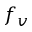Convert formula to latex. <formula><loc_0><loc_0><loc_500><loc_500>f _ { v }</formula> 